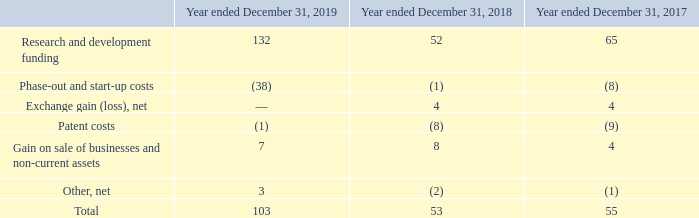Other income and expenses, net consisted of the following:
The Company receives significant public funding from governmental agencies in several jurisdictions. Public funding for research and development is recognized ratably as the related costs are incurred once the agreement with the respective governmental agency has been signed and all applicable conditions have been met.
R&D funding received in the year ended December 31, 2017 from the Nano2017 program with the French government is subject to a financial return in the year 2024 and depends on the future cumulative sales of a certain product group from 2019 to 2024. As such, an accrual amounting to $47 million was recorded as of December 31, 2019 compared to $42 million as of December 31, 2018.
Phase-out costs are costs incurred during the closing stage of a Company’s manufacturing facility. They are treated in the same manner as start-up costs. Start-up costs represent costs incurred in the start-up and testing of the Company’s new manufacturing facilities, before reaching the earlier of a minimum level of production or six months after the fabrication line’s quality certification.
Exchange gains and losses, net represent the portion of exchange rate changes on transactions denominated in currencies other than an entity’s functional currency and the changes in fair value of trading derivative instruments which are not designated as hedge and which have a cash flow effect related to operating transactions, as described in Note 27.
Patent costs include legal and attorney fees and payment for claims, patent pre-litigation consultancy and legal fees. They are reported net of settlements, if any, which primarily include reimbursements of prior patent litigation costs.
In 2019, gain on sale of businesses and non-current assets was related to the sale of one of our non-strategic assets. In 2018, it was related to the sale of one of the Company’s non-strategic investments while in 2017, it
was related to the sale of assets.
Which government supported the R&D funding? French government. What are start-up costs? Start-up costs represent costs incurred in the start-up and testing of the company’s new manufacturing facilities, before reaching the earlier of a minimum level of production or six months after the fabrication line’s quality certification. What is included in the patent costs? Patent costs include legal and attorney fees and payment for claims, patent pre-litigation consultancy and legal fees. What is the average Research and development funding? (132+52+65) / 3
Answer: 83. What is the average Phase-out and start-up costs? (38+1+8) / 3
Answer: 15.67. What is the average Patent costs? (1+8+9) / 3
Answer: 6. 